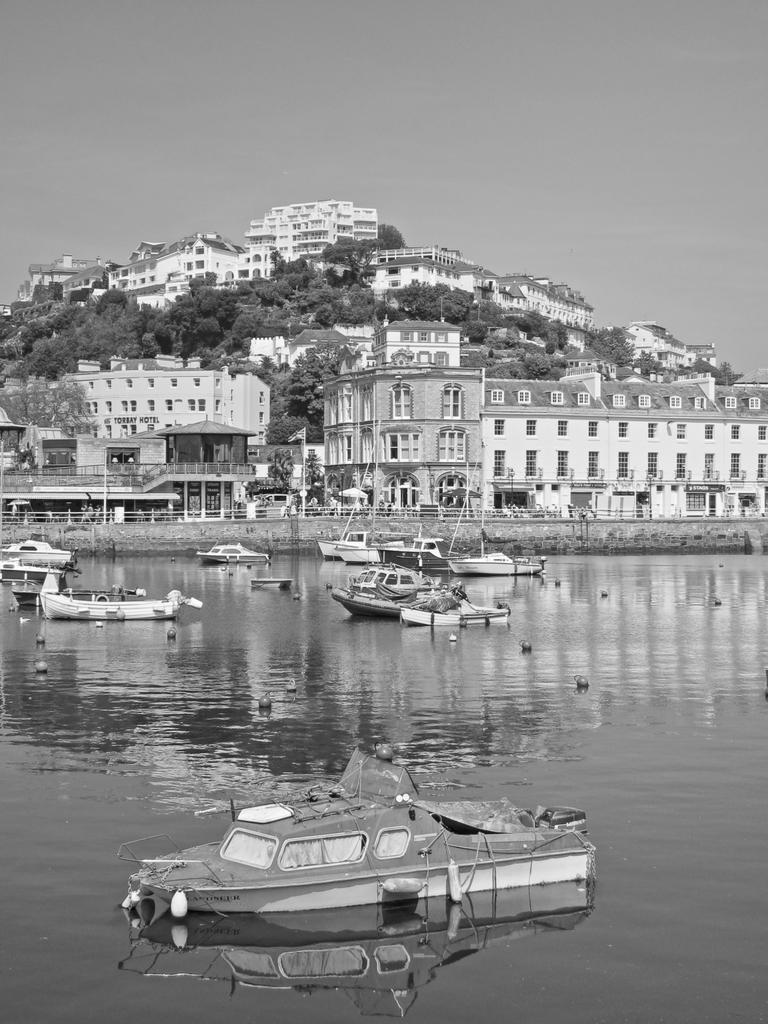In one or two sentences, can you explain what this image depicts? This is a black and white image. There are a few buildings and trees. We can also see the sky. There are a few ships sailing on the water. We can also see some objects on the top of the water. We can see the fence and the wall. 